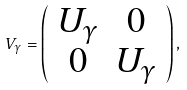<formula> <loc_0><loc_0><loc_500><loc_500>V _ { \gamma } = \left ( \begin{array} { c c } U _ { \gamma } & 0 \\ 0 & U _ { \gamma } \end{array} \right ) ,</formula> 